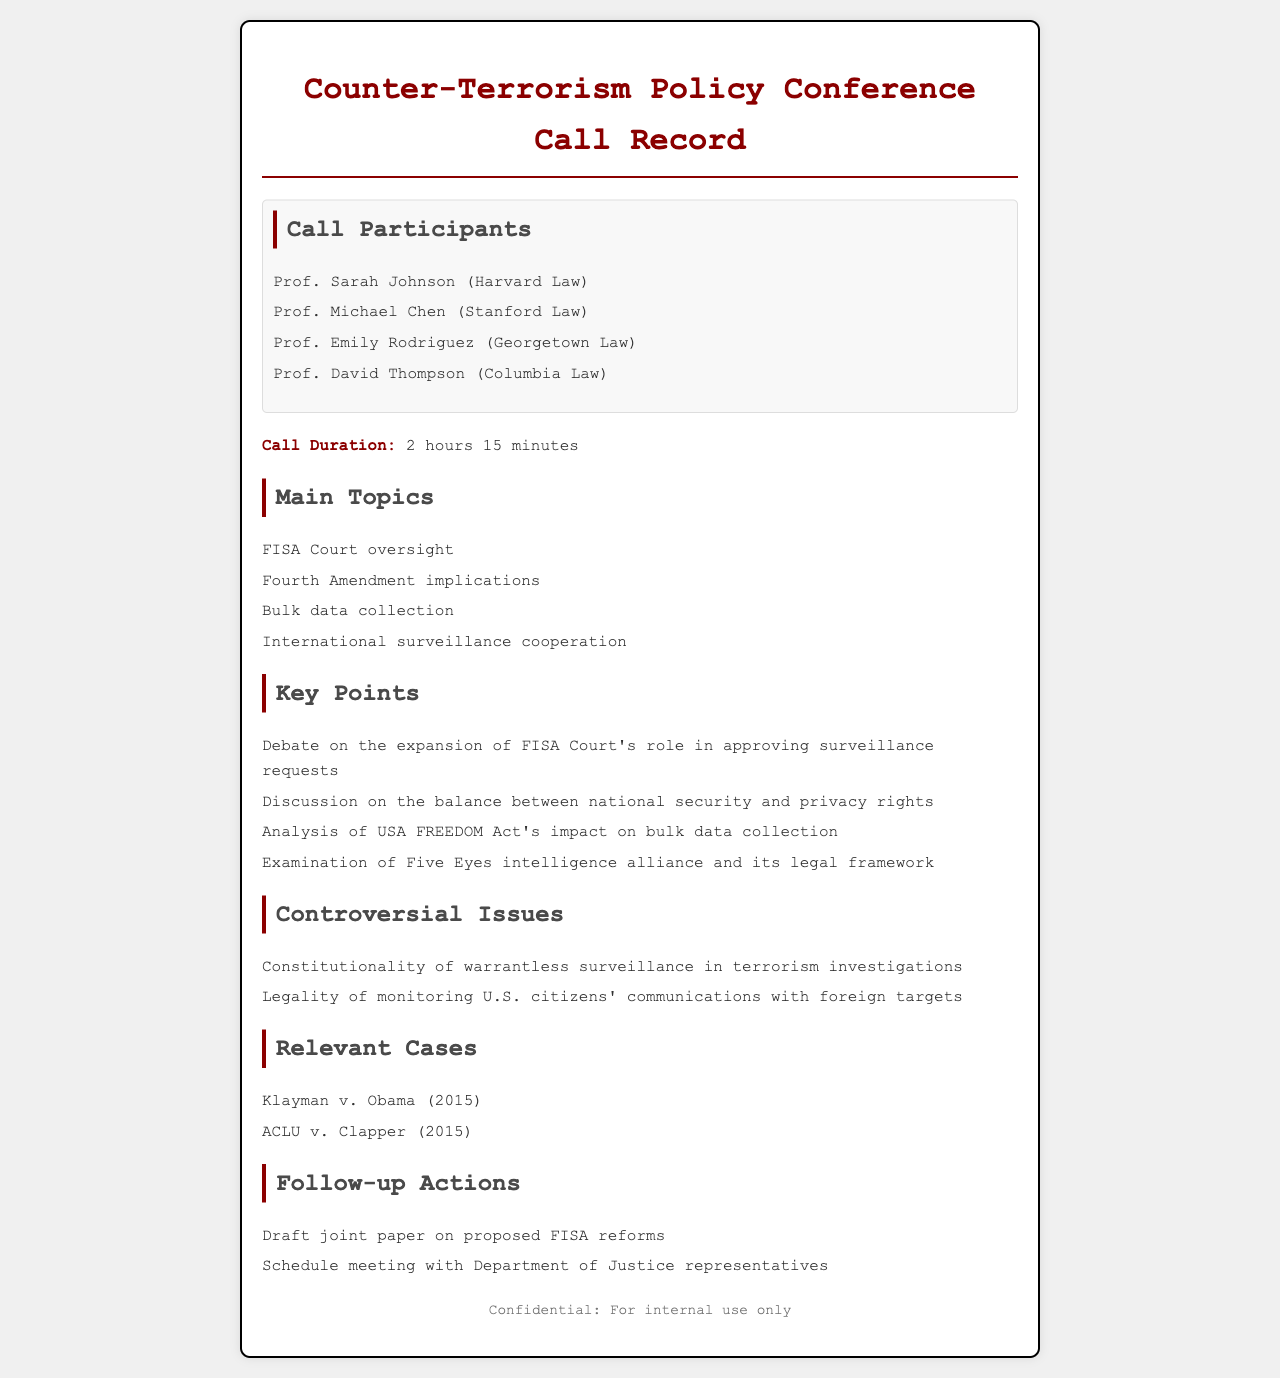What is the call duration? The call duration is a specific detail mentioned in the document, providing the total length of the conference call.
Answer: 2 hours 15 minutes Who is the participant from Stanford Law? This asks for a specific participant’s name and their affiliated institution present in the call.
Answer: Prof. Michael Chen What is one controversial issue discussed? It requires identifying a specific controversial issue mentioned in the document regarding counter-terrorism policies.
Answer: Constitutionality of warrantless surveillance in terrorism investigations How many key points are listed? This question inquires about a count of specific items presented in the document under the Key Points section.
Answer: 4 What action is proposed regarding FISA reforms? This seeks a concise statement about follow-up action related to FISA reforms indicated in the document.
Answer: Draft joint paper on proposed FISA reforms Which case is mentioned in relevance to the conversation? This question asks for a specific case that is referenced for context in the conversation about surveillance.
Answer: Klayman v. Obama (2015) What is the primary focus of the debate? This requires extracting the main focus or theme discussed during the call based on the listed topics.
Answer: Balance between national security and privacy rights How many participants were on the call? This question seeks a count of the individuals who participated in the conference call.
Answer: 4 